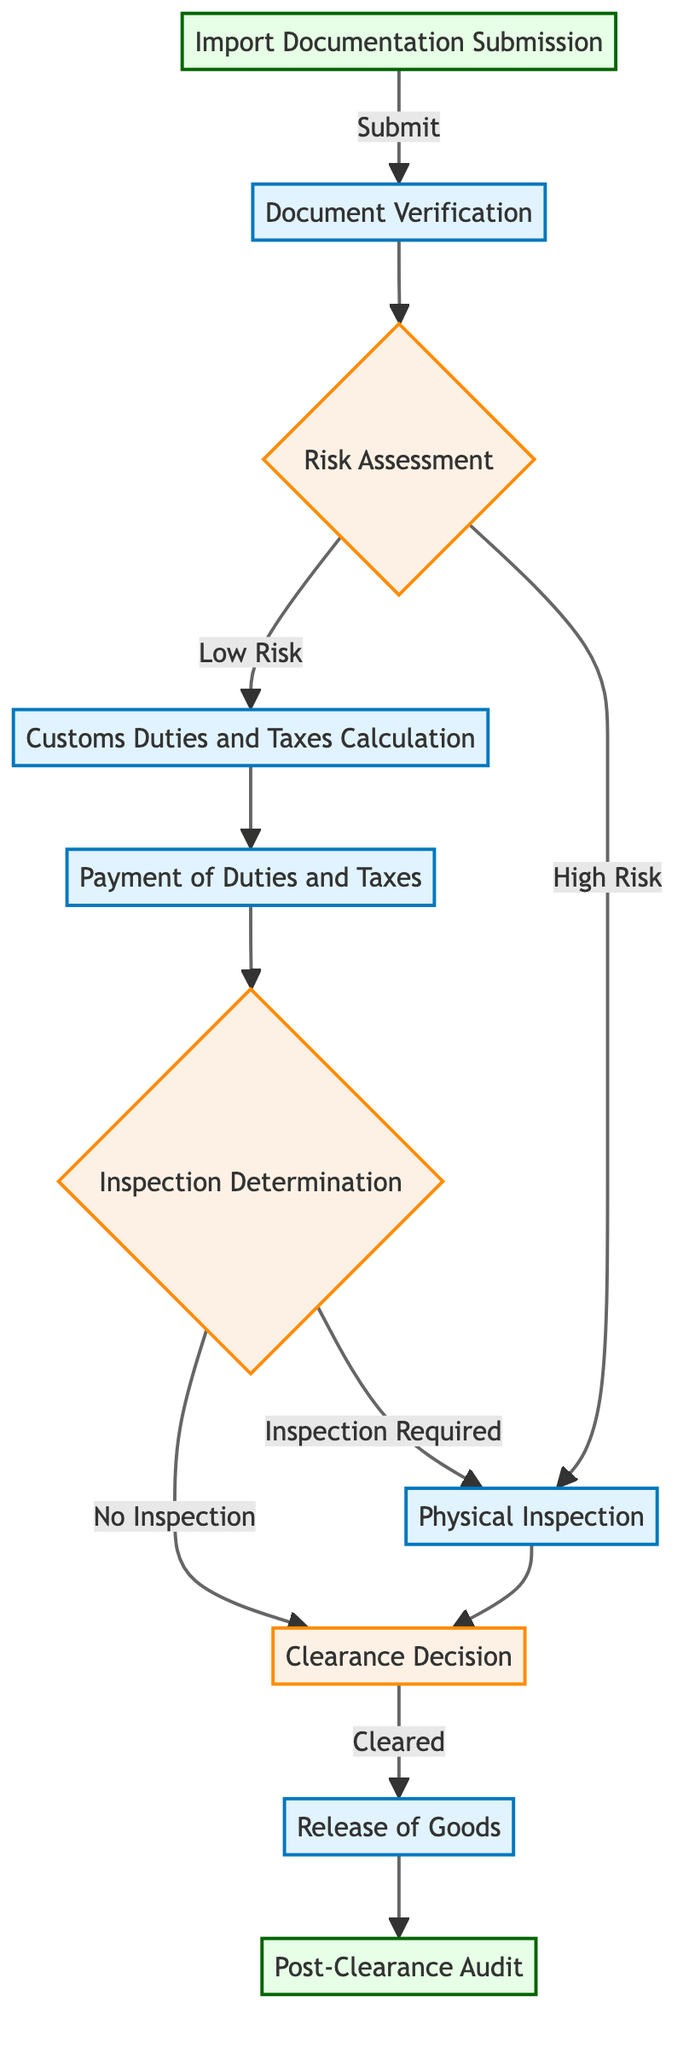What is the first step in the customs clearance process? The first step in the customs clearance process is "Import Documentation Submission." This is where the required import documents are submitted to the Customs Authority.
Answer: Import Documentation Submission How many main decision points are present in the flowchart? In the flowchart, there are three main decision points: "Risk Assessment," "Inspection Determination," and "Clearance Decision." These points require further evaluation before proceeding.
Answer: 3 What happens if the risk assessment determines that the shipment is high risk? If the risk assessment determines that the shipment is high risk, the process moves to "Physical Inspection," where a detailed examination of the shipment is conducted.
Answer: Physical Inspection Which entities are involved in paying customs duties and taxes? The entities involved in the payment of customs duties and taxes are the "Importer" and "Banking Institutions" as they facilitate the payment process.
Answer: Importer, Banking Institutions After successful customs clearance, what is the next step? After successful customs clearance, the next step is the "Release of Goods," where the goods are released to the importer after all requirements are met.
Answer: Release of Goods What condition allows goods to proceed to clearance decision without inspection? If the inspection determination finds that no inspection is required (i.e., low risk), the goods can proceed directly to the "Clearance Decision."
Answer: No Inspection How does the customs authority evaluate the need for physical inspection? The customs authority evaluates the need for physical inspection based on the outcomes of the risk assessment and any identified red flags from the assessment.
Answer: Risk Assessment outcomes and red flags What step occurs immediately after the payment of duties and taxes? Immediately after the payment of duties and taxes, the step that follows is "Inspection Determination," where it is decided if further inspection is necessary.
Answer: Inspection Determination 